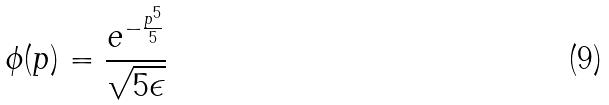Convert formula to latex. <formula><loc_0><loc_0><loc_500><loc_500>\phi ( p ) = \frac { e ^ { - \frac { p ^ { 5 } } { 5 } } } { \sqrt { 5 \epsilon } }</formula> 